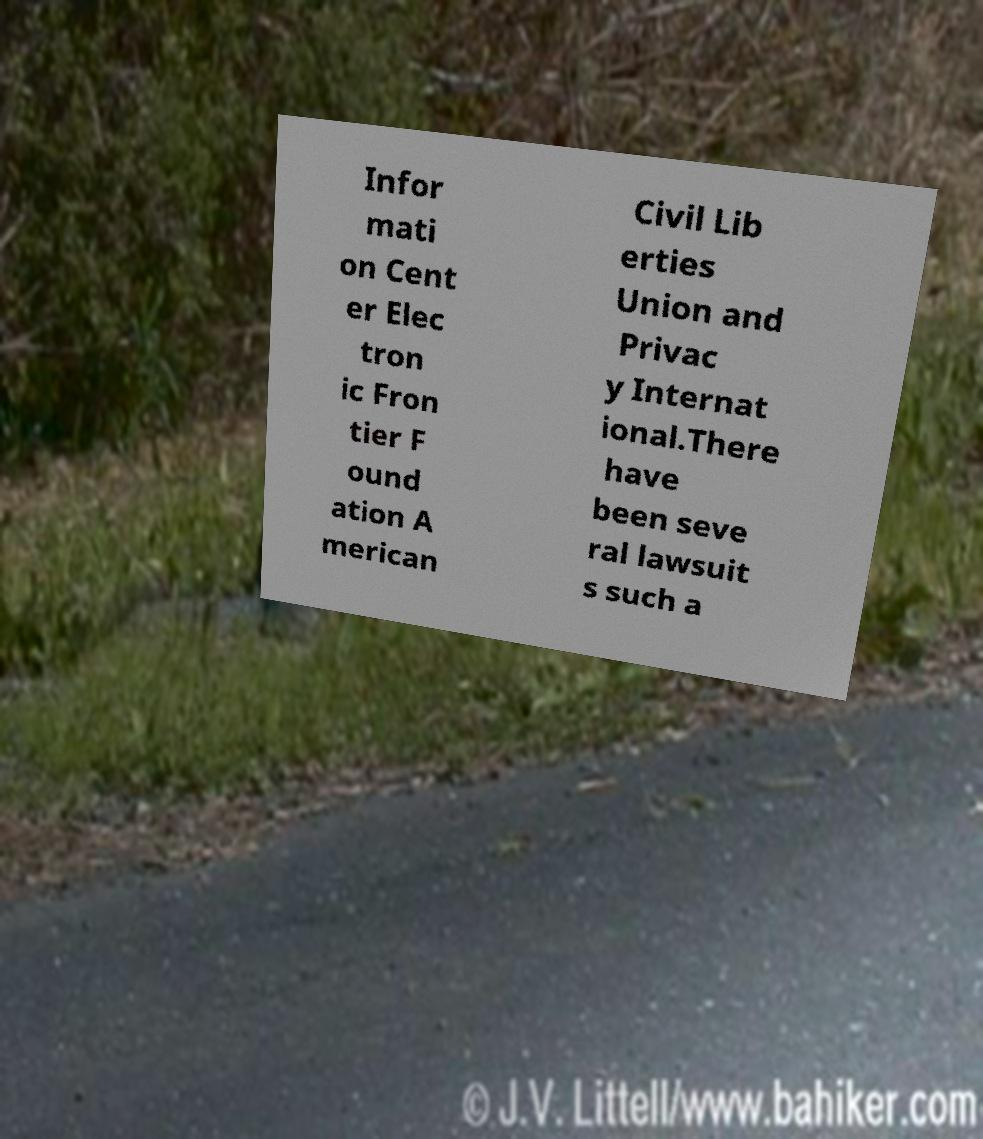There's text embedded in this image that I need extracted. Can you transcribe it verbatim? Infor mati on Cent er Elec tron ic Fron tier F ound ation A merican Civil Lib erties Union and Privac y Internat ional.There have been seve ral lawsuit s such a 